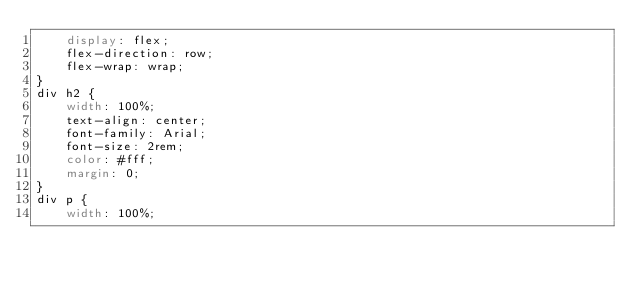Convert code to text. <code><loc_0><loc_0><loc_500><loc_500><_CSS_>    display: flex;
    flex-direction: row;
    flex-wrap: wrap;
}
div h2 {
    width: 100%;
    text-align: center;
    font-family: Arial;
    font-size: 2rem;
    color: #fff;
    margin: 0;
}
div p {
    width: 100%;</code> 